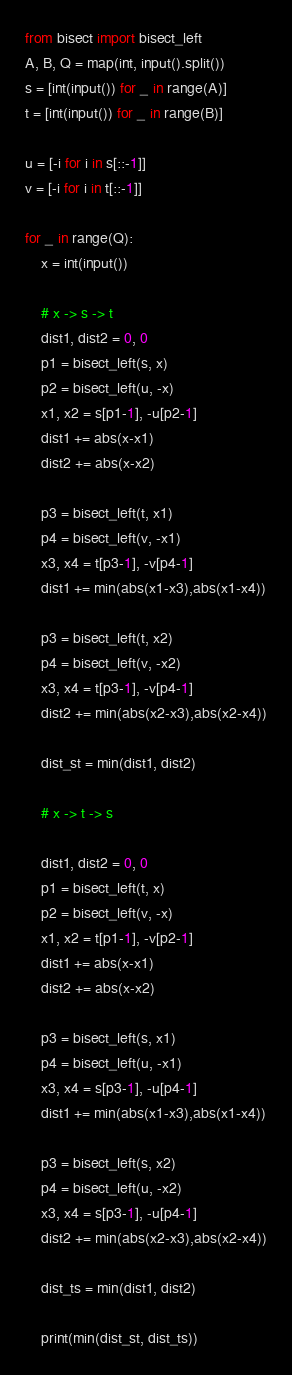<code> <loc_0><loc_0><loc_500><loc_500><_Python_>from bisect import bisect_left
A, B, Q = map(int, input().split())
s = [int(input()) for _ in range(A)]
t = [int(input()) for _ in range(B)]

u = [-i for i in s[::-1]]
v = [-i for i in t[::-1]]

for _ in range(Q):
    x = int(input())

    # x -> s -> t
    dist1, dist2 = 0, 0
    p1 = bisect_left(s, x)
    p2 = bisect_left(u, -x)
    x1, x2 = s[p1-1], -u[p2-1]
    dist1 += abs(x-x1)
    dist2 += abs(x-x2)

    p3 = bisect_left(t, x1)
    p4 = bisect_left(v, -x1)
    x3, x4 = t[p3-1], -v[p4-1]
    dist1 += min(abs(x1-x3),abs(x1-x4))

    p3 = bisect_left(t, x2)
    p4 = bisect_left(v, -x2)
    x3, x4 = t[p3-1], -v[p4-1]
    dist2 += min(abs(x2-x3),abs(x2-x4))

    dist_st = min(dist1, dist2)

    # x -> t -> s

    dist1, dist2 = 0, 0
    p1 = bisect_left(t, x)
    p2 = bisect_left(v, -x)
    x1, x2 = t[p1-1], -v[p2-1]
    dist1 += abs(x-x1)
    dist2 += abs(x-x2)

    p3 = bisect_left(s, x1)
    p4 = bisect_left(u, -x1)
    x3, x4 = s[p3-1], -u[p4-1]
    dist1 += min(abs(x1-x3),abs(x1-x4))

    p3 = bisect_left(s, x2)
    p4 = bisect_left(u, -x2)
    x3, x4 = s[p3-1], -u[p4-1]
    dist2 += min(abs(x2-x3),abs(x2-x4))

    dist_ts = min(dist1, dist2)

    print(min(dist_st, dist_ts))</code> 